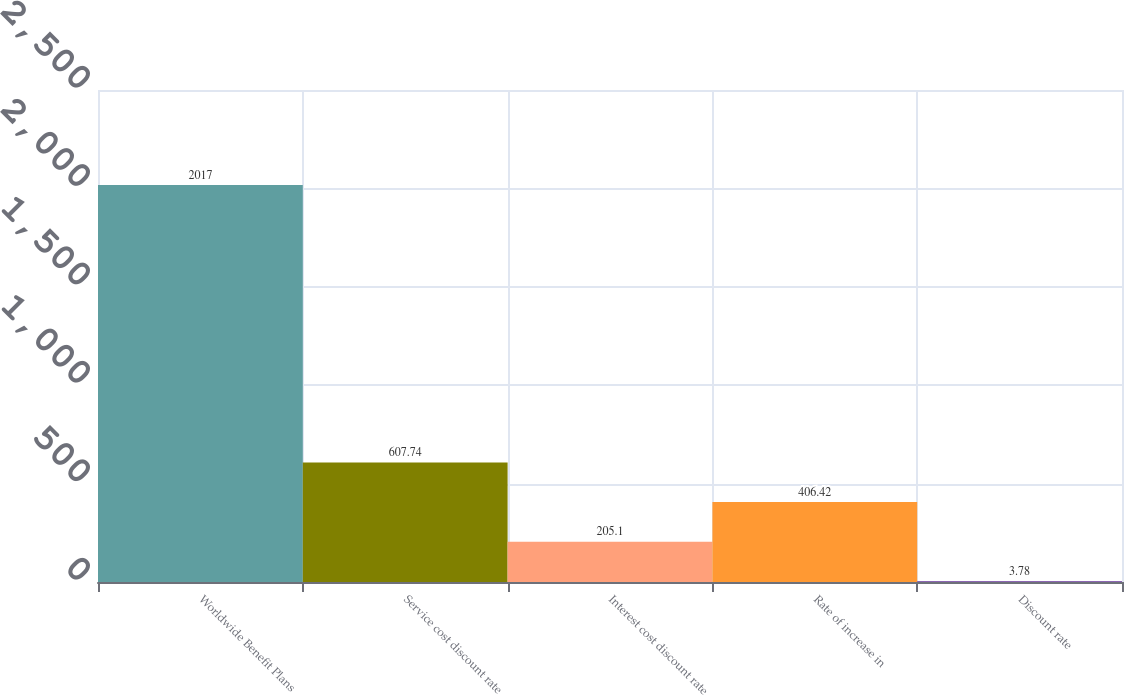Convert chart to OTSL. <chart><loc_0><loc_0><loc_500><loc_500><bar_chart><fcel>Worldwide Benefit Plans<fcel>Service cost discount rate<fcel>Interest cost discount rate<fcel>Rate of increase in<fcel>Discount rate<nl><fcel>2017<fcel>607.74<fcel>205.1<fcel>406.42<fcel>3.78<nl></chart> 